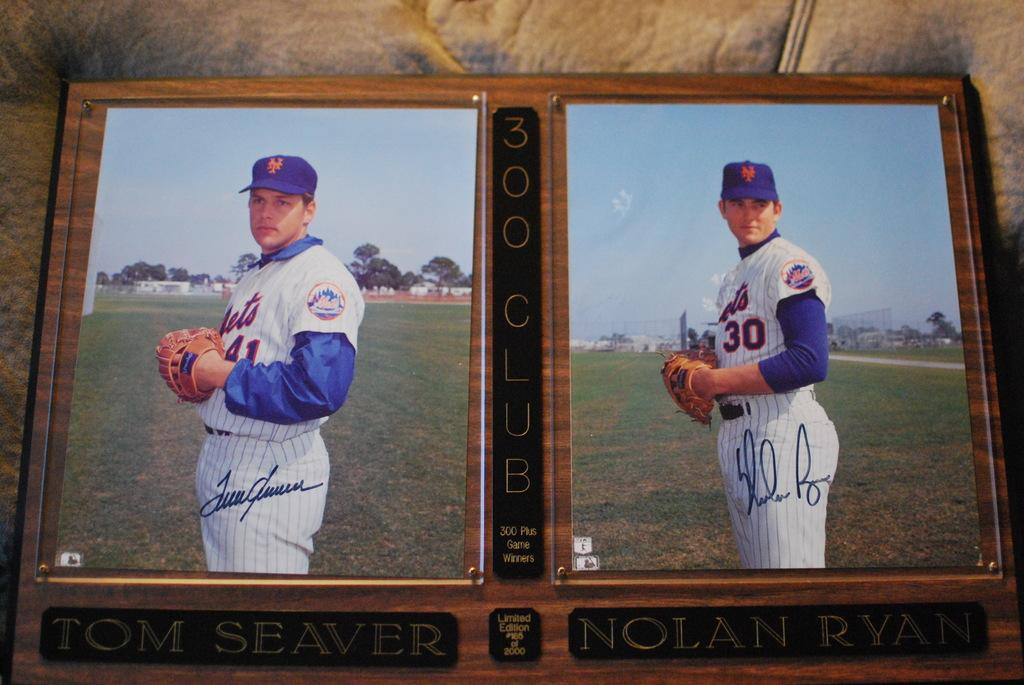<image>
Render a clear and concise summary of the photo. A 300 Club baseball photo display of Tom Seaver and Nolan Ryan 